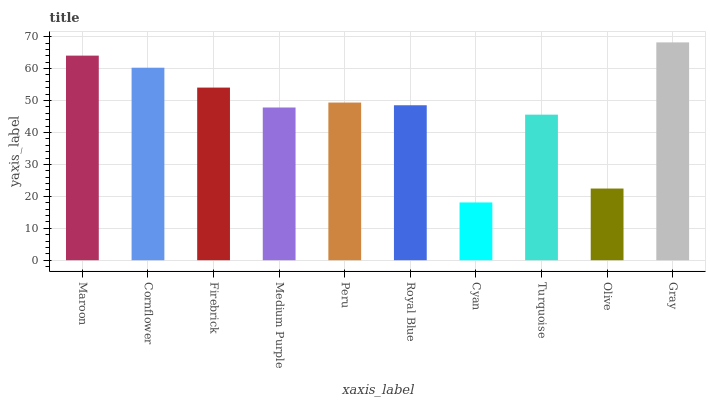Is Cyan the minimum?
Answer yes or no. Yes. Is Gray the maximum?
Answer yes or no. Yes. Is Cornflower the minimum?
Answer yes or no. No. Is Cornflower the maximum?
Answer yes or no. No. Is Maroon greater than Cornflower?
Answer yes or no. Yes. Is Cornflower less than Maroon?
Answer yes or no. Yes. Is Cornflower greater than Maroon?
Answer yes or no. No. Is Maroon less than Cornflower?
Answer yes or no. No. Is Peru the high median?
Answer yes or no. Yes. Is Royal Blue the low median?
Answer yes or no. Yes. Is Cornflower the high median?
Answer yes or no. No. Is Peru the low median?
Answer yes or no. No. 